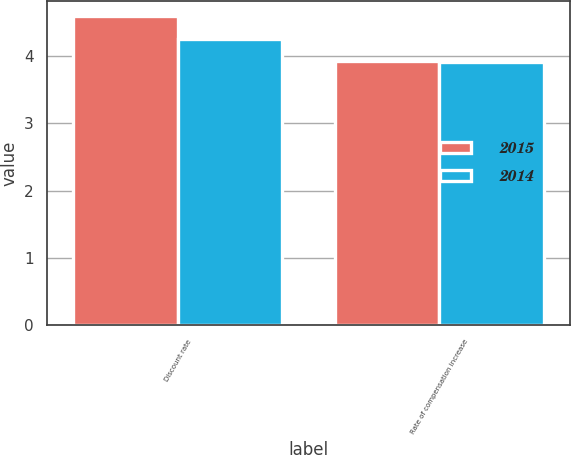Convert chart. <chart><loc_0><loc_0><loc_500><loc_500><stacked_bar_chart><ecel><fcel>Discount rate<fcel>Rate of compensation increase<nl><fcel>2015<fcel>4.59<fcel>3.93<nl><fcel>2014<fcel>4.25<fcel>3.91<nl></chart> 